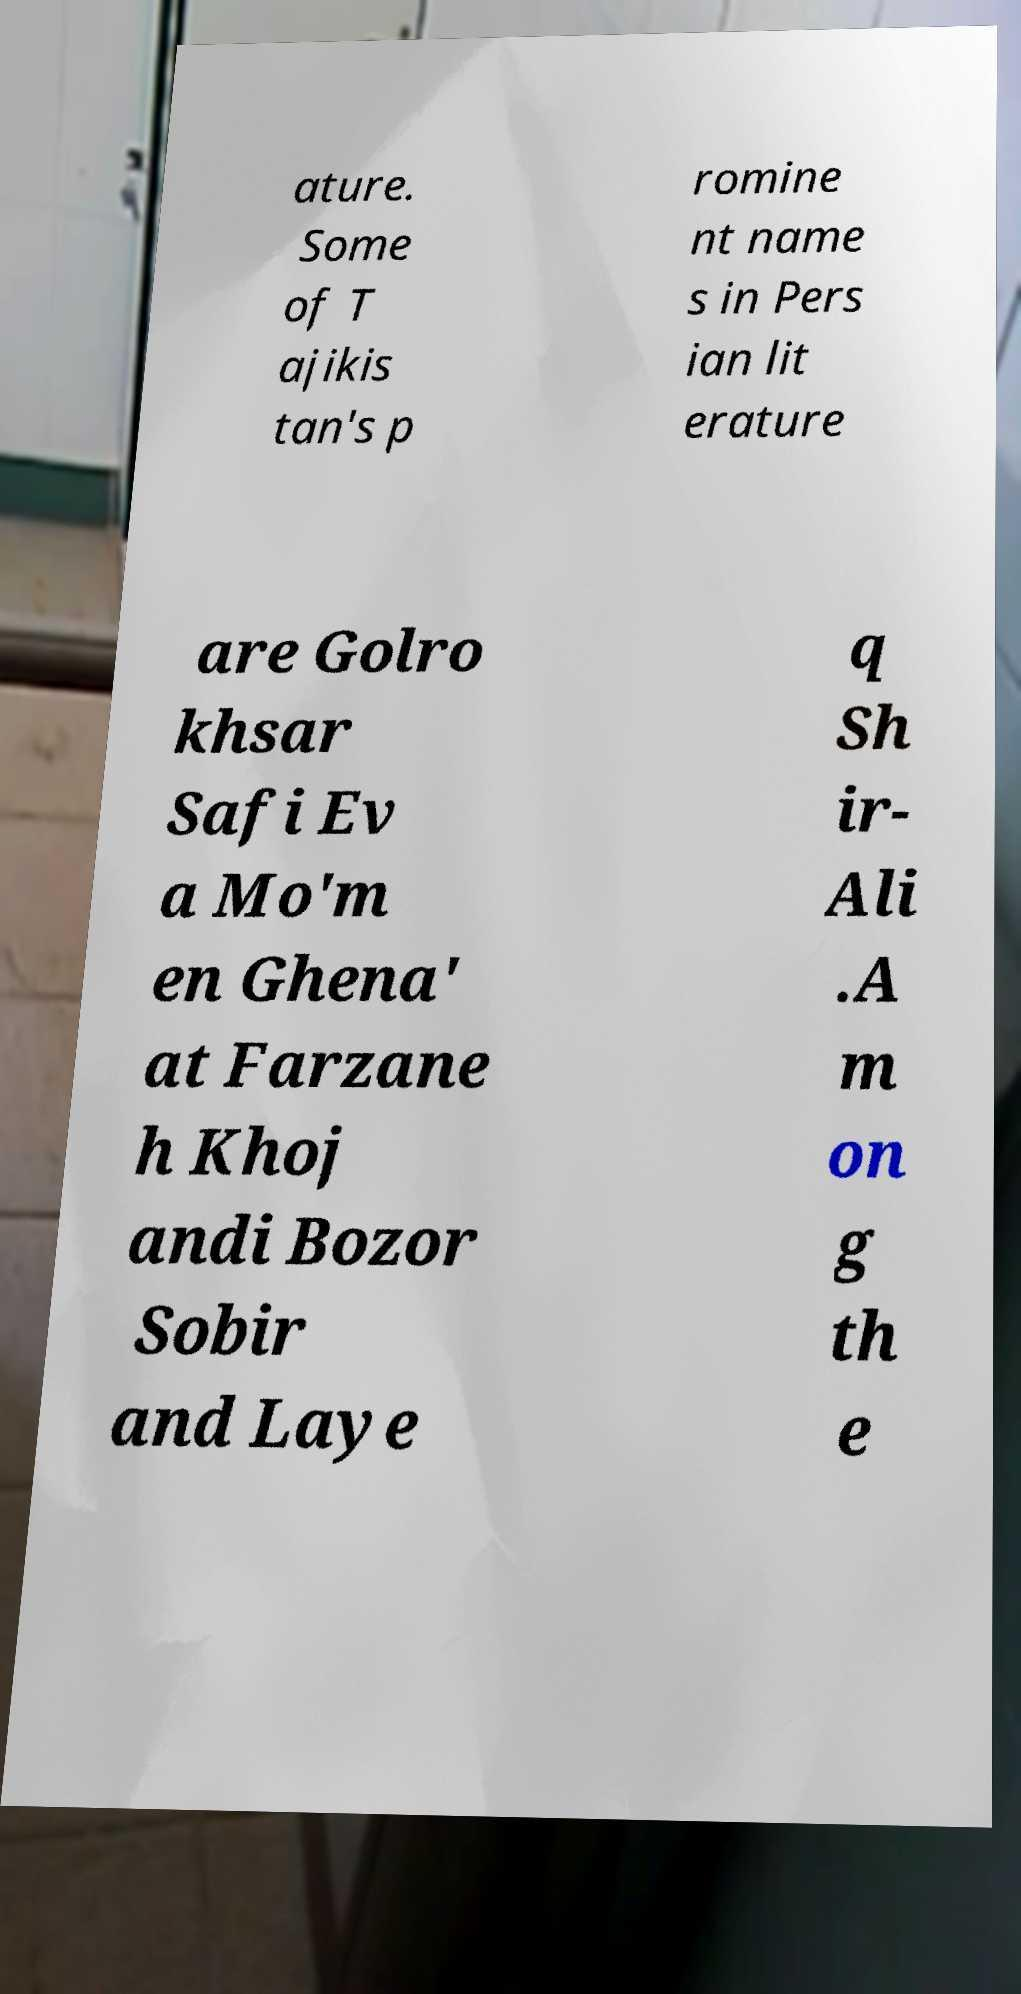Can you accurately transcribe the text from the provided image for me? ature. Some of T ajikis tan's p romine nt name s in Pers ian lit erature are Golro khsar Safi Ev a Mo'm en Ghena' at Farzane h Khoj andi Bozor Sobir and Laye q Sh ir- Ali .A m on g th e 